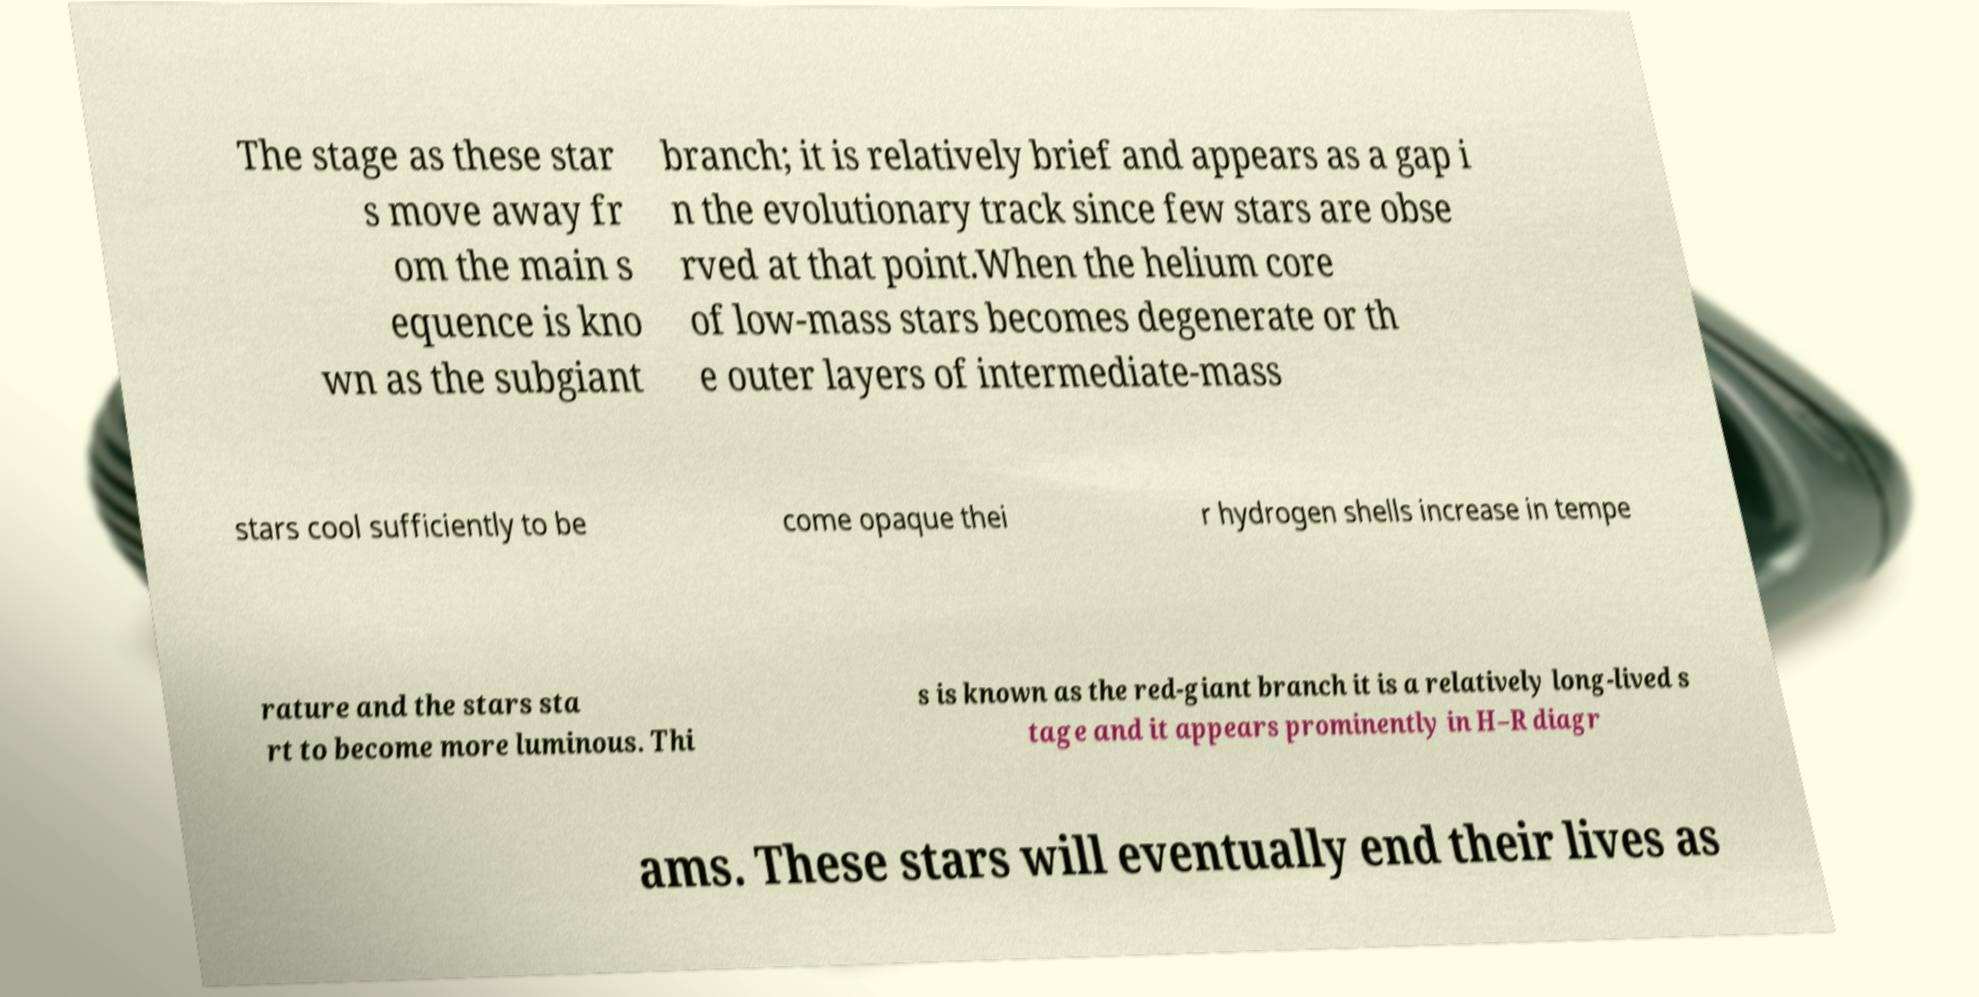Please identify and transcribe the text found in this image. The stage as these star s move away fr om the main s equence is kno wn as the subgiant branch; it is relatively brief and appears as a gap i n the evolutionary track since few stars are obse rved at that point.When the helium core of low-mass stars becomes degenerate or th e outer layers of intermediate-mass stars cool sufficiently to be come opaque thei r hydrogen shells increase in tempe rature and the stars sta rt to become more luminous. Thi s is known as the red-giant branch it is a relatively long-lived s tage and it appears prominently in H–R diagr ams. These stars will eventually end their lives as 